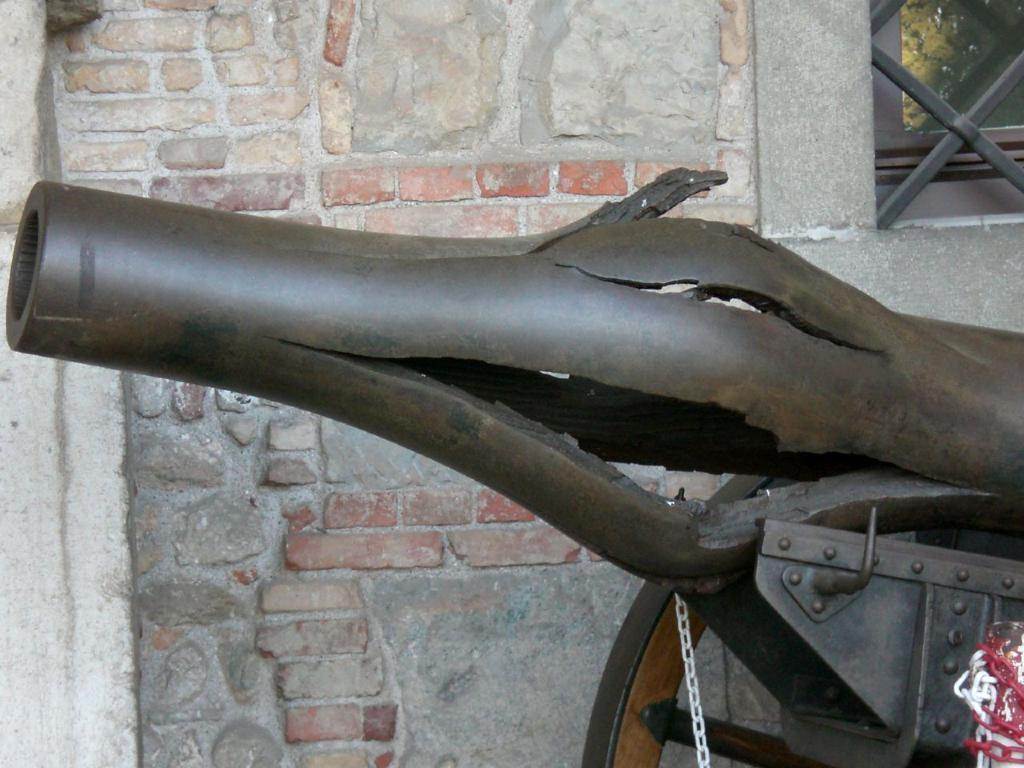What object in the image can be used as a weapon? There is a weapon in the image. What can be seen on the right side of the image? There are chains on the right side of the image. What is visible in the background of the image? There is a wall and a tree in the background of the image. What position does the church hold in the image? There is no church present in the image. How does the weapon attack the chains in the image? The weapon does not attack the chains in the image; it is a static object. 